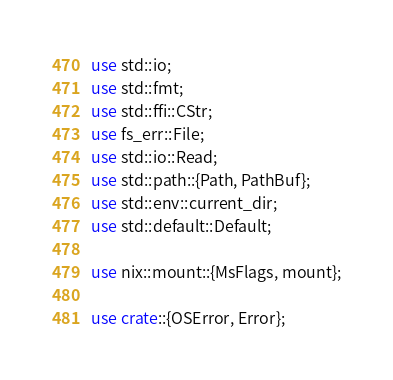<code> <loc_0><loc_0><loc_500><loc_500><_Rust_>use std::io;
use std::fmt;
use std::ffi::CStr;
use fs_err::File;
use std::io::Read;
use std::path::{Path, PathBuf};
use std::env::current_dir;
use std::default::Default;

use nix::mount::{MsFlags, mount};

use crate::{OSError, Error};</code> 